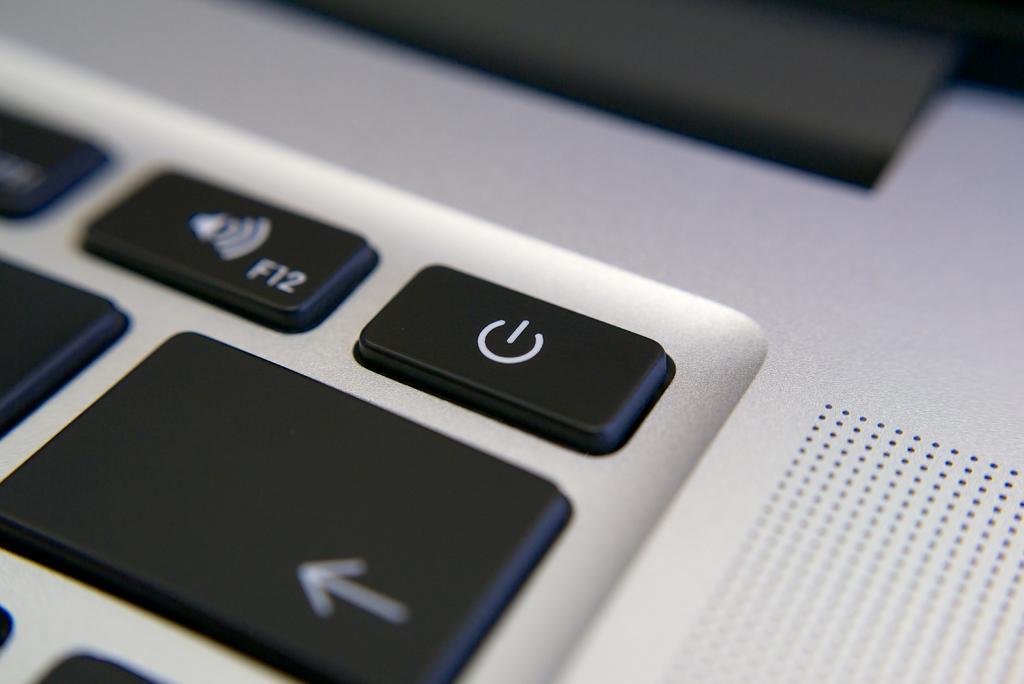What key also has a speaker symbol on it?
Provide a succinct answer. F12. 